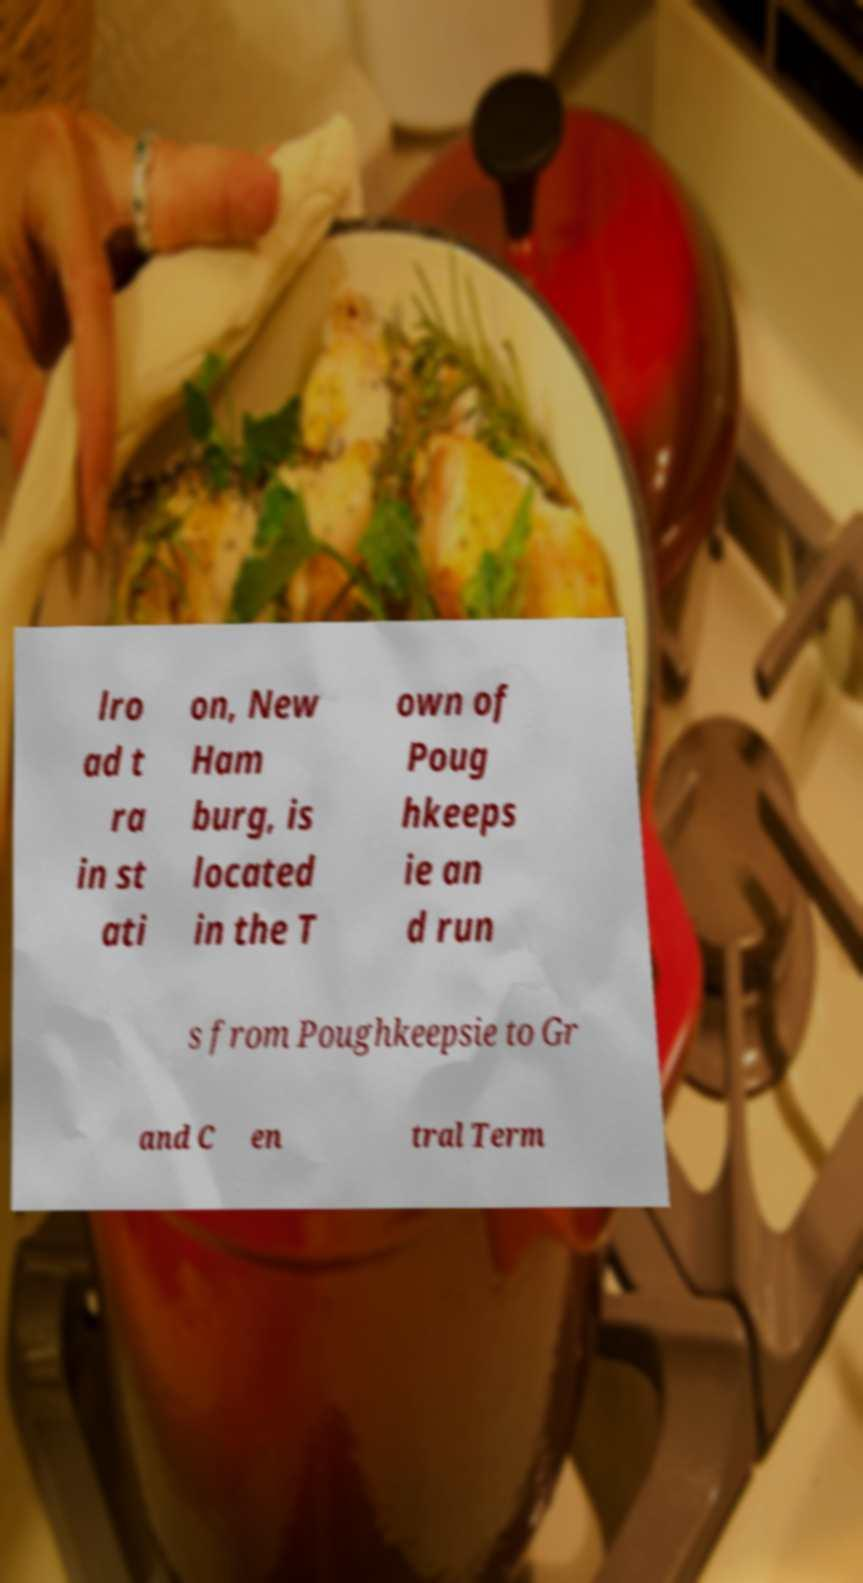There's text embedded in this image that I need extracted. Can you transcribe it verbatim? lro ad t ra in st ati on, New Ham burg, is located in the T own of Poug hkeeps ie an d run s from Poughkeepsie to Gr and C en tral Term 